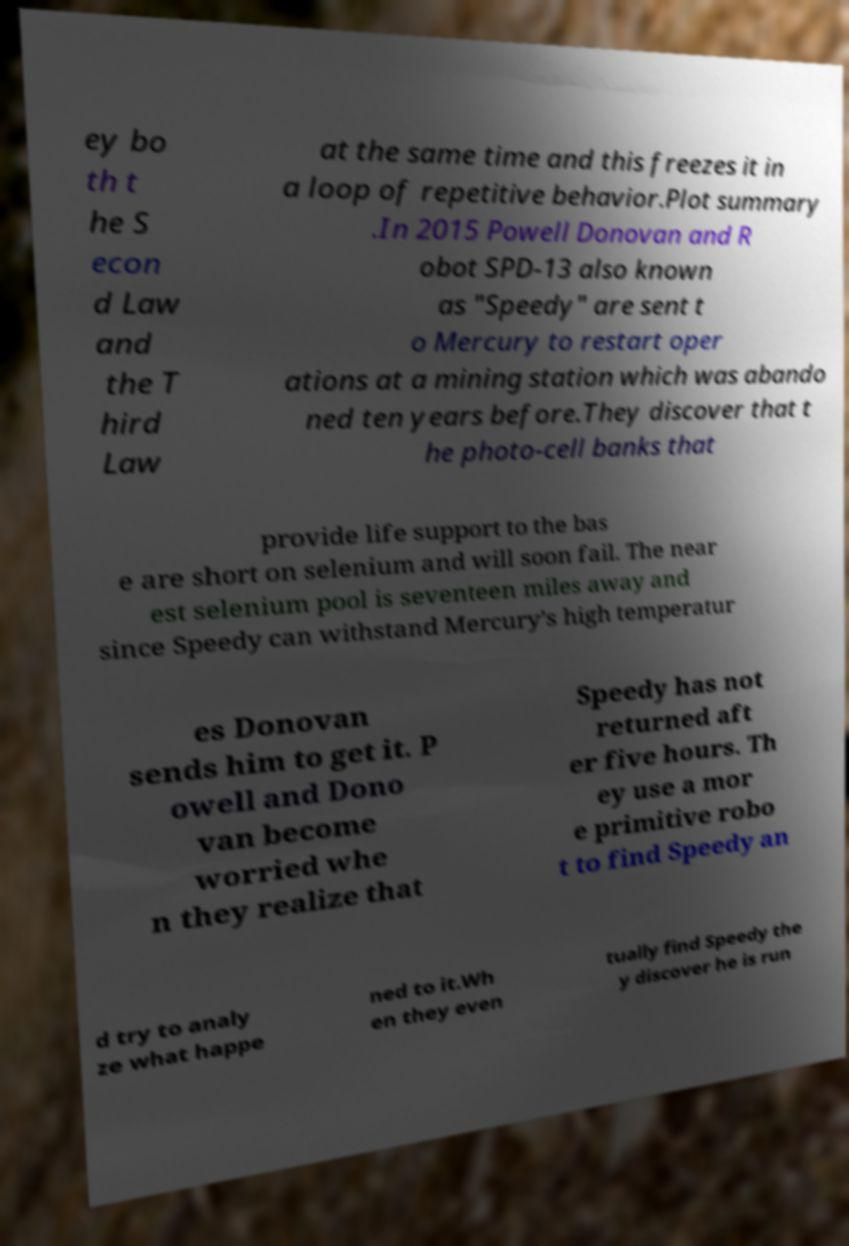I need the written content from this picture converted into text. Can you do that? ey bo th t he S econ d Law and the T hird Law at the same time and this freezes it in a loop of repetitive behavior.Plot summary .In 2015 Powell Donovan and R obot SPD-13 also known as "Speedy" are sent t o Mercury to restart oper ations at a mining station which was abando ned ten years before.They discover that t he photo-cell banks that provide life support to the bas e are short on selenium and will soon fail. The near est selenium pool is seventeen miles away and since Speedy can withstand Mercury’s high temperatur es Donovan sends him to get it. P owell and Dono van become worried whe n they realize that Speedy has not returned aft er five hours. Th ey use a mor e primitive robo t to find Speedy an d try to analy ze what happe ned to it.Wh en they even tually find Speedy the y discover he is run 